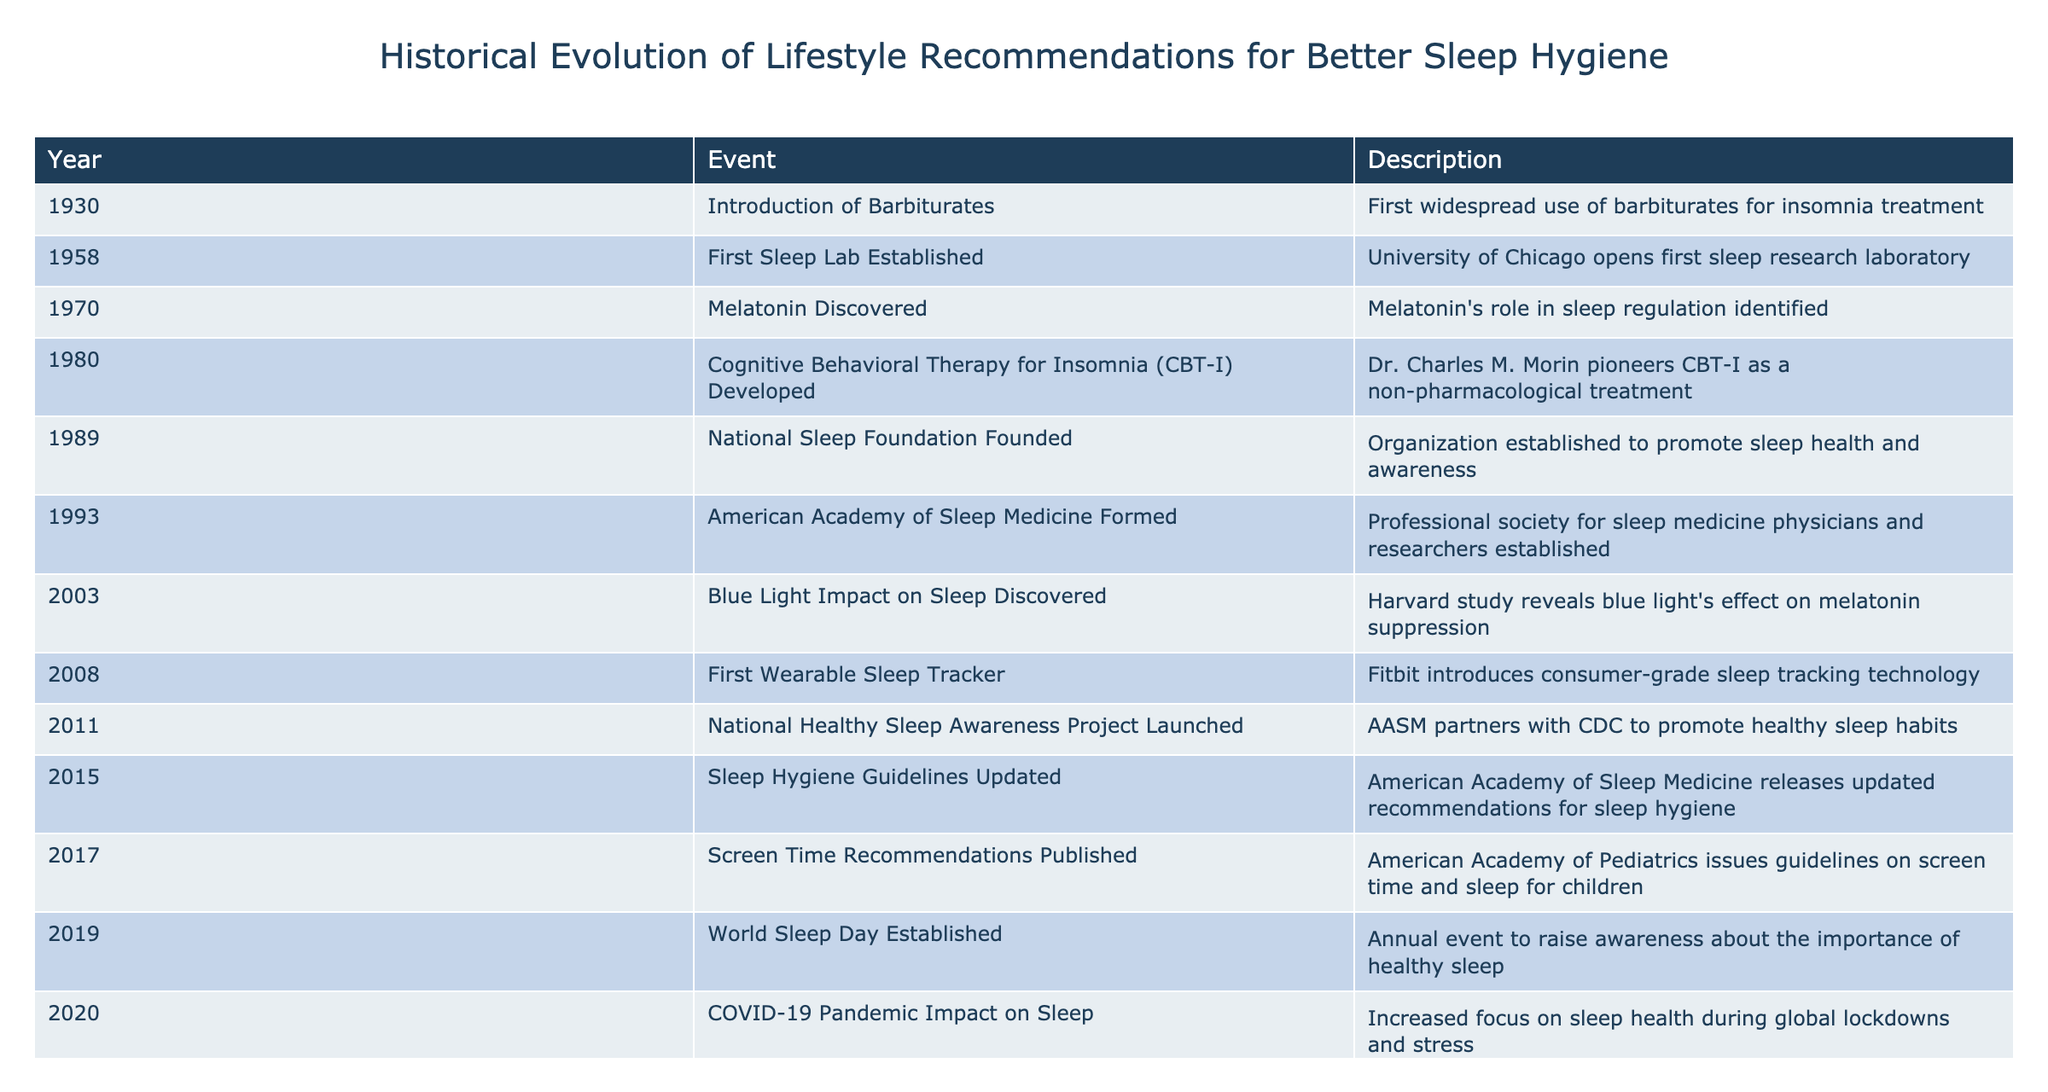What year was CBT-I developed? According to the table, Cognitive Behavioral Therapy for Insomnia (CBT-I) was developed in 1980.
Answer: 1980 What was the main focus of the National Healthy Sleep Awareness Project launched in 2011? In 2011, the National Healthy Sleep Awareness Project was launched to promote healthy sleep habits, as mentioned in the description.
Answer: Promote healthy sleep habits Was the first sleep lab established before or after the introduction of barbiturates for insomnia treatment? The first sleep lab was established in 1958, while barbiturates were introduced in 1930, indicating that the lab opening came after the introduction of barbiturates.
Answer: After How many years elapsed between the discovery of melatonin and the year the National Sleep Foundation was founded? Melatonin was discovered in 1970, and the National Sleep Foundation was founded in 1989. The years between 1970 and 1989 are 19 years apart.
Answer: 19 years What percentage of events in the table are focused on promoting healthy sleep habits? There are 2 events specifically mentioning "promote" related to healthy sleep habits (2011, 2015) out of 13 total events, so the percentage is (2/13) * 100 ≈ 15.38%.
Answer: Approximately 15.38% What is the significance of the year 2020 in the context of sleep health? In 2020, the COVID-19 pandemic impacted sleep health due to increased focus during global lockdowns and stress, which indicates a significant societal awareness surrounding sleep issues at that time.
Answer: Increased focus on sleep health Which events occurred after 2000 that relate to tracking or measuring sleep? After 2000, events related to tracking sleep include the introduction of the first wearable sleep tracker in 2008 and the gaining popularity of digital CBT apps in 2022, showing a trend towards technology in sleep measurement.
Answer: Two events: 2008 and 2022 Was the impact of blue light on sleep known before or after the National Sleep Foundation was founded? The blue light impact on sleep was discovered in 2003, which is before the National Sleep Foundation was founded in 1989, indicating that the knowledge about blue light’s effects on sleep came later.
Answer: Before What major development in sleep medicine took place in 1993? The American Academy of Sleep Medicine was formed in 1993, which is a key event in the establishment of professional standards and research in sleep medicine.
Answer: Formation of the American Academy of Sleep Medicine 